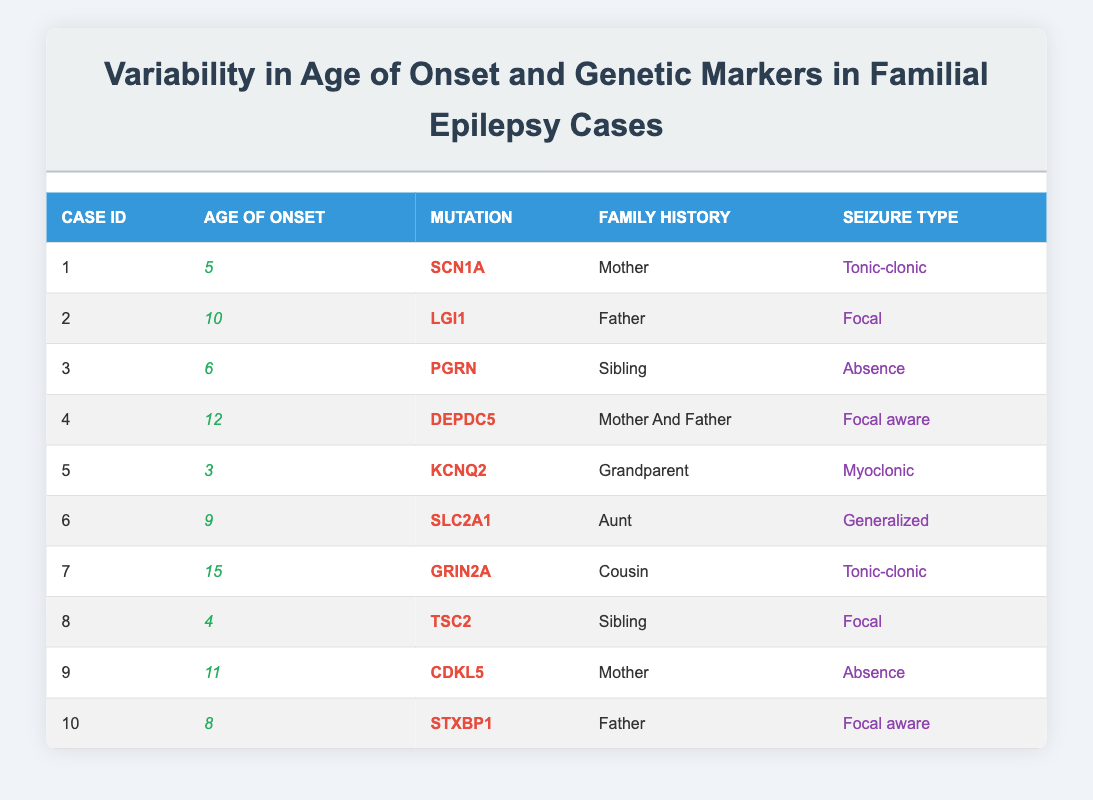What is the age of onset for case ID 4? From the table, I can find case ID 4, which is listed in the second column under "Age of Onset." The value there is 12.
Answer: 12 What mutation is associated with case ID 2? Looking at case ID 2 in the table, the corresponding mutation is listed in the third column under "Mutation," which shows LGI1.
Answer: LGI1 How many of the cases have a family history that includes the mother? To find this, I will review the "Family History" column for each case. Cases 1, 4, and 9 fit this criterion. There are three cases in total.
Answer: 3 What is the average age of onset among the cases listed? I will add all the ages of onset together, which gives (5 + 10 + 6 + 12 + 3 + 9 + 15 + 4 + 11 + 8) = 93. There are 10 cases, so the average age of onset is 93/10 = 9.3.
Answer: 9.3 Is there any case where the age of onset is less than 5? Reviewing the "Age of Onset" column, the smallest value is 3 (case ID 5), which is indeed less than 5.
Answer: Yes Which seizure type appears most frequently in the cases? Looking through the "Seizure Type" column, the types are tonic-clonic, focal, absence, focal aware, myoclonic, and generalized. Tonic-clonic appears twice (cases 1 and 7), while focal appears three times (cases 2, 4, and 8). Thus, focal is the most frequent.
Answer: Focal Are there any cases with a mutation known to be associated with a higher age of onset? From the data, we need to check if any mutations have previous research associating them with late onset. In this dataset, case ID 7 with mutation GRIN2A has the highest age of onset (15), indicating a possible correlation. So, yes, there is at least one case that fits the criterion.
Answer: Yes What is the seizure type for the case with the youngest age of onset? The youngest age of onset is 3, which is associated with case ID 5, and upon checking the "Seizure Type" column for this case, it shows myoclonic.
Answer: Myoclonic Is it true that all cases with a family history including a grandmother show a specific mutation? Checking the "Family History" column, case ID 5 is the only case with a family history of a grandparent, and its mutation is KCNQ2. Since there is only one case, the statement cannot be generalized to other cases with a grandmother. So, the answer is no.
Answer: No 